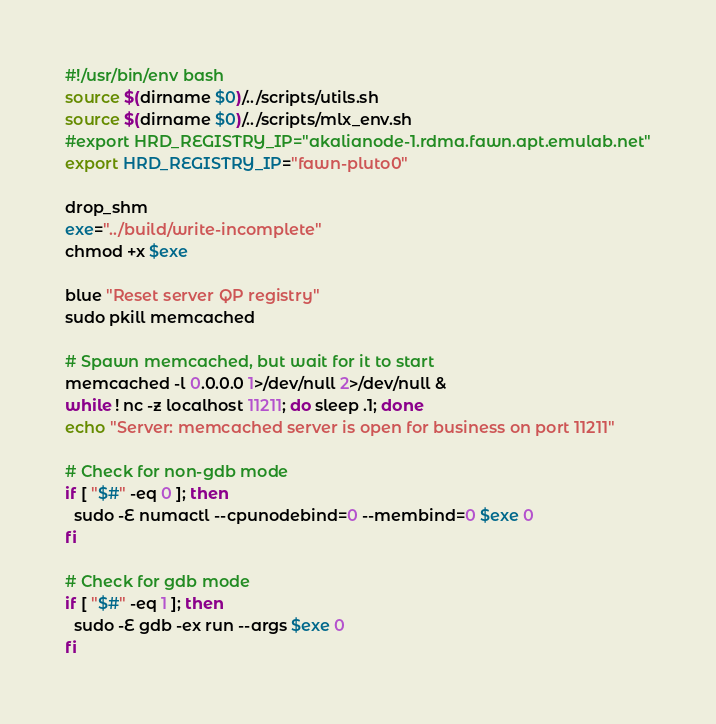<code> <loc_0><loc_0><loc_500><loc_500><_Bash_>#!/usr/bin/env bash
source $(dirname $0)/../scripts/utils.sh
source $(dirname $0)/../scripts/mlx_env.sh
#export HRD_REGISTRY_IP="akalianode-1.rdma.fawn.apt.emulab.net"
export HRD_REGISTRY_IP="fawn-pluto0"

drop_shm
exe="../build/write-incomplete"
chmod +x $exe

blue "Reset server QP registry"
sudo pkill memcached

# Spawn memcached, but wait for it to start
memcached -l 0.0.0.0 1>/dev/null 2>/dev/null &
while ! nc -z localhost 11211; do sleep .1; done
echo "Server: memcached server is open for business on port 11211"

# Check for non-gdb mode
if [ "$#" -eq 0 ]; then
  sudo -E numactl --cpunodebind=0 --membind=0 $exe 0
fi

# Check for gdb mode
if [ "$#" -eq 1 ]; then
  sudo -E gdb -ex run --args $exe 0
fi
</code> 